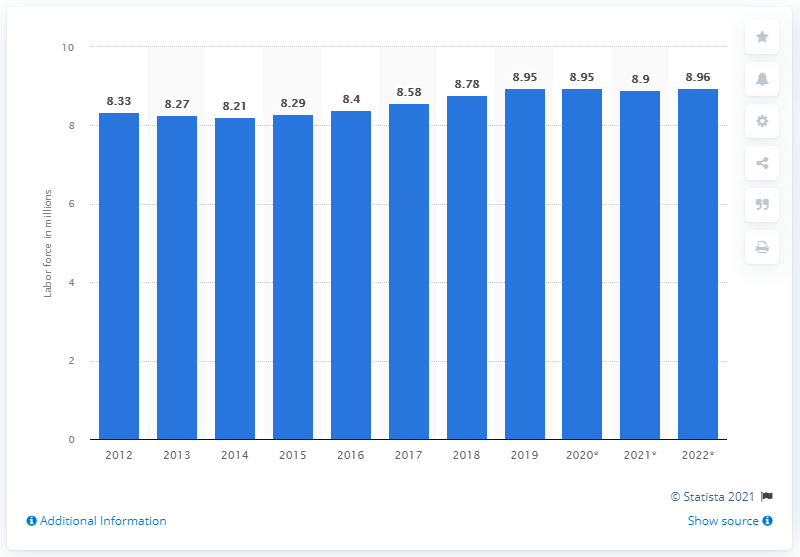Indicate a few pertinent items in this graphic. In 2019, the Netherlands had approximately 8.96 million people employed. In 2012, employment in the Netherlands began to increase. 